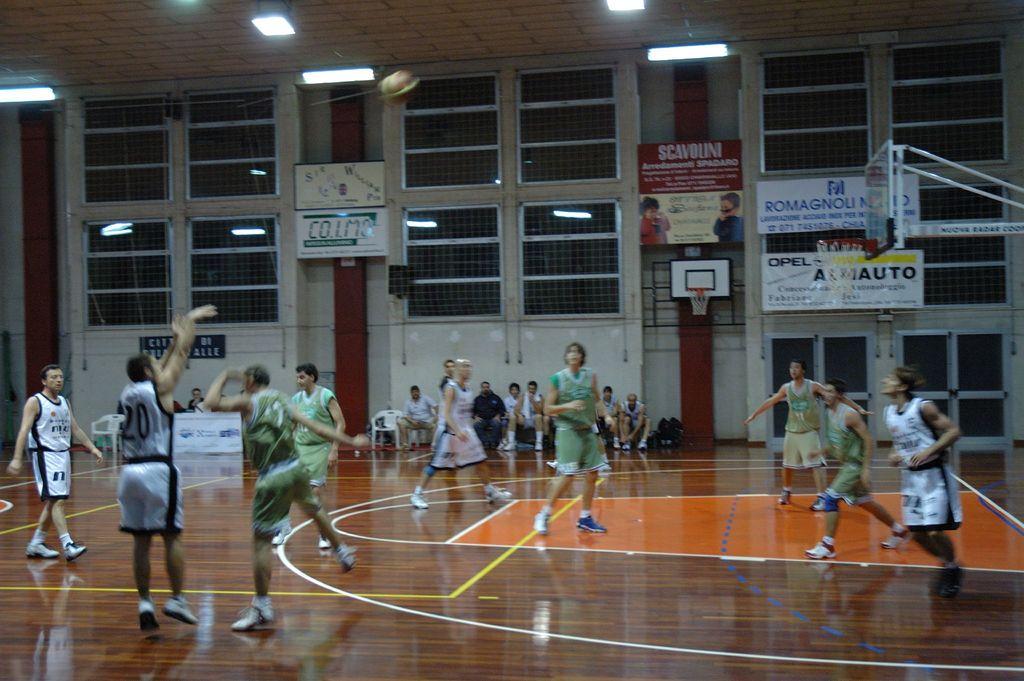What is the text on the red sign?
Offer a terse response. Scavolini. 